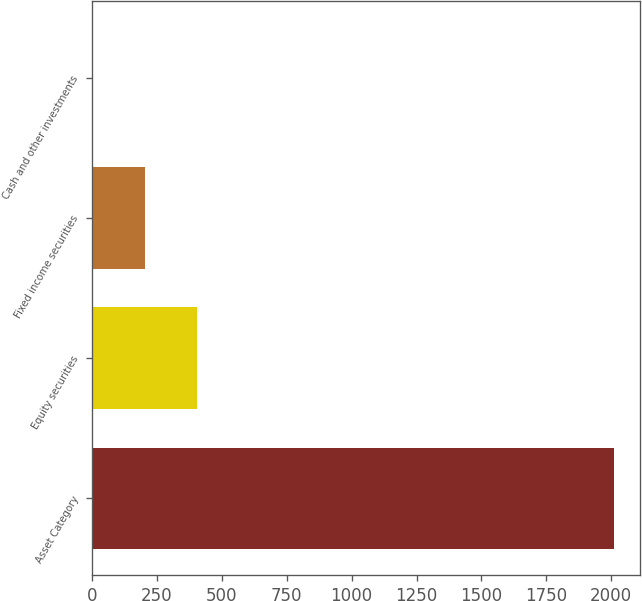<chart> <loc_0><loc_0><loc_500><loc_500><bar_chart><fcel>Asset Category<fcel>Equity securities<fcel>Fixed income securities<fcel>Cash and other investments<nl><fcel>2012<fcel>403.2<fcel>202.1<fcel>1<nl></chart> 